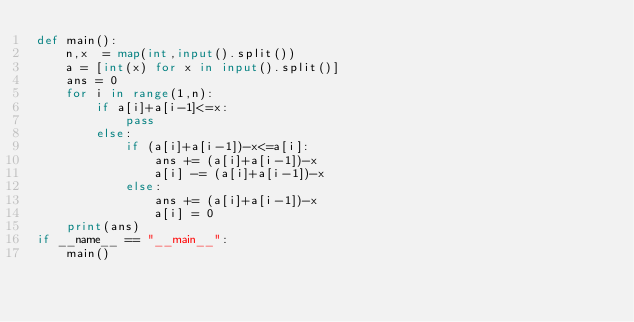Convert code to text. <code><loc_0><loc_0><loc_500><loc_500><_Python_>def main():
    n,x  = map(int,input().split())
    a = [int(x) for x in input().split()]
    ans = 0
    for i in range(1,n):
        if a[i]+a[i-1]<=x:
            pass
        else:
            if (a[i]+a[i-1])-x<=a[i]:
                ans += (a[i]+a[i-1])-x
                a[i] -= (a[i]+a[i-1])-x
            else:
                ans += (a[i]+a[i-1])-x 
                a[i] = 0
    print(ans)
if __name__ == "__main__":
    main()</code> 